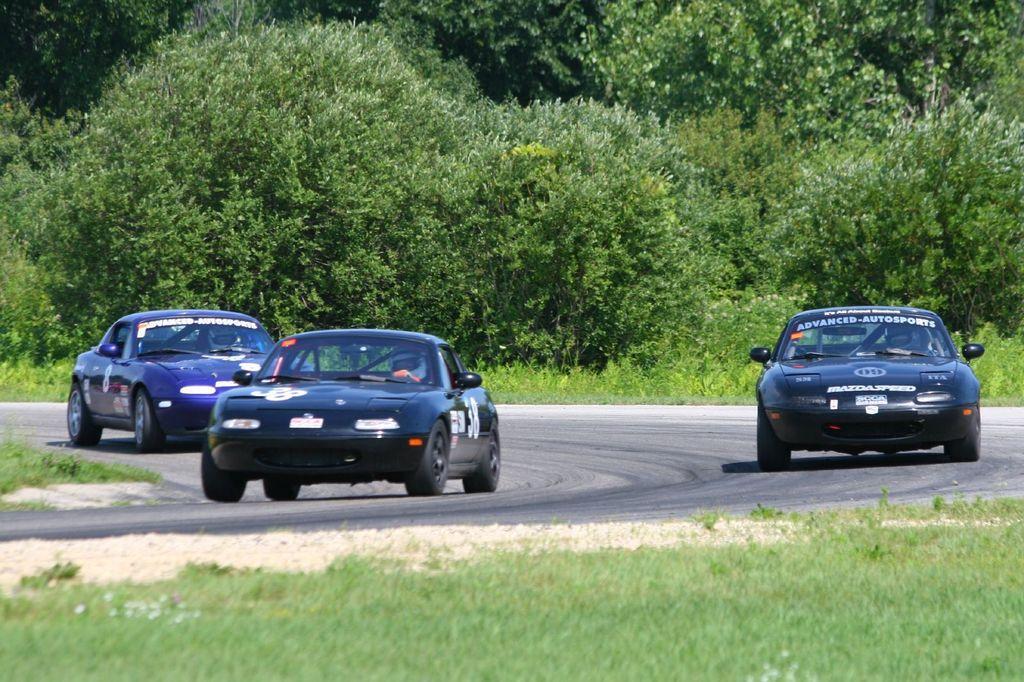How would you summarize this image in a sentence or two? Here there are cars on the road, here there are trees and these is grass. 